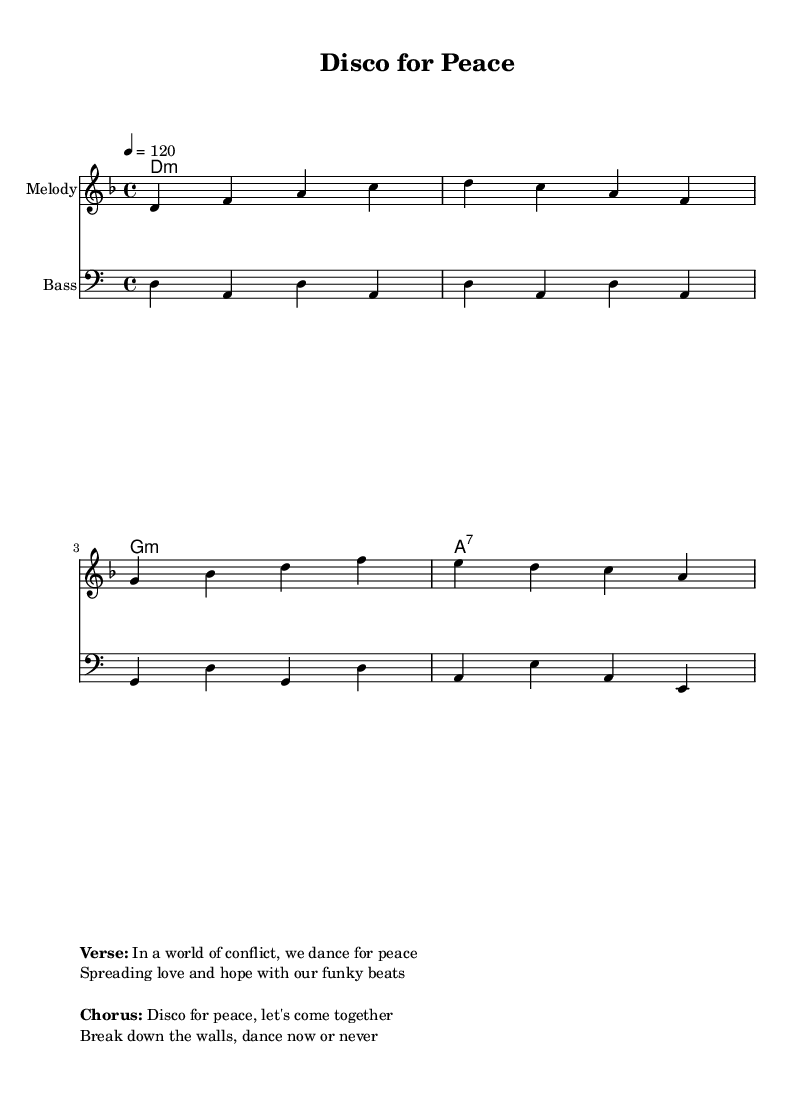What is the key signature of this music? The key signature is D minor, which has one flat (B flat). This is deduced from the key notation at the beginning of the score, which indicates the music is composed in D minor.
Answer: D minor What is the time signature of this music? The time signature is 4/4, as indicated at the beginning of the piece. This means there are four beats in each measure, with the quarter note getting one beat.
Answer: 4/4 What is the tempo marking for this piece? The tempo is marked as 4 = 120, indicating that there are 120 beats per minute, with each quarter note receiving one beat. This gives the music a lively disco rhythm.
Answer: 120 How many measures are there in the melody? The melody consists of four measures. This can be counted by looking at the grouping of notes and the change of measures, clearly divided by vertical lines in the score.
Answer: 4 What type of chords are primarily used in the harmonies? The harmonies primarily use minor chords, which are indicated by the 'm' notation after the chord letters in the chord line. This is typical for creating a soulful, emotional feel in disco music.
Answer: minor What thematic message is suggested in the verse of the lyrics? The thematic message in the verse emphasizes peace while promoting love and hope through dance, reflecting the socially conscious nature of the disco song. This is derived from the lyrics presented alongside the score.
Answer: peace 